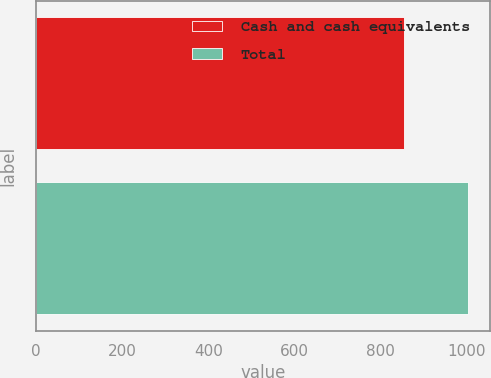Convert chart. <chart><loc_0><loc_0><loc_500><loc_500><bar_chart><fcel>Cash and cash equivalents<fcel>Total<nl><fcel>855.1<fcel>1004.1<nl></chart> 